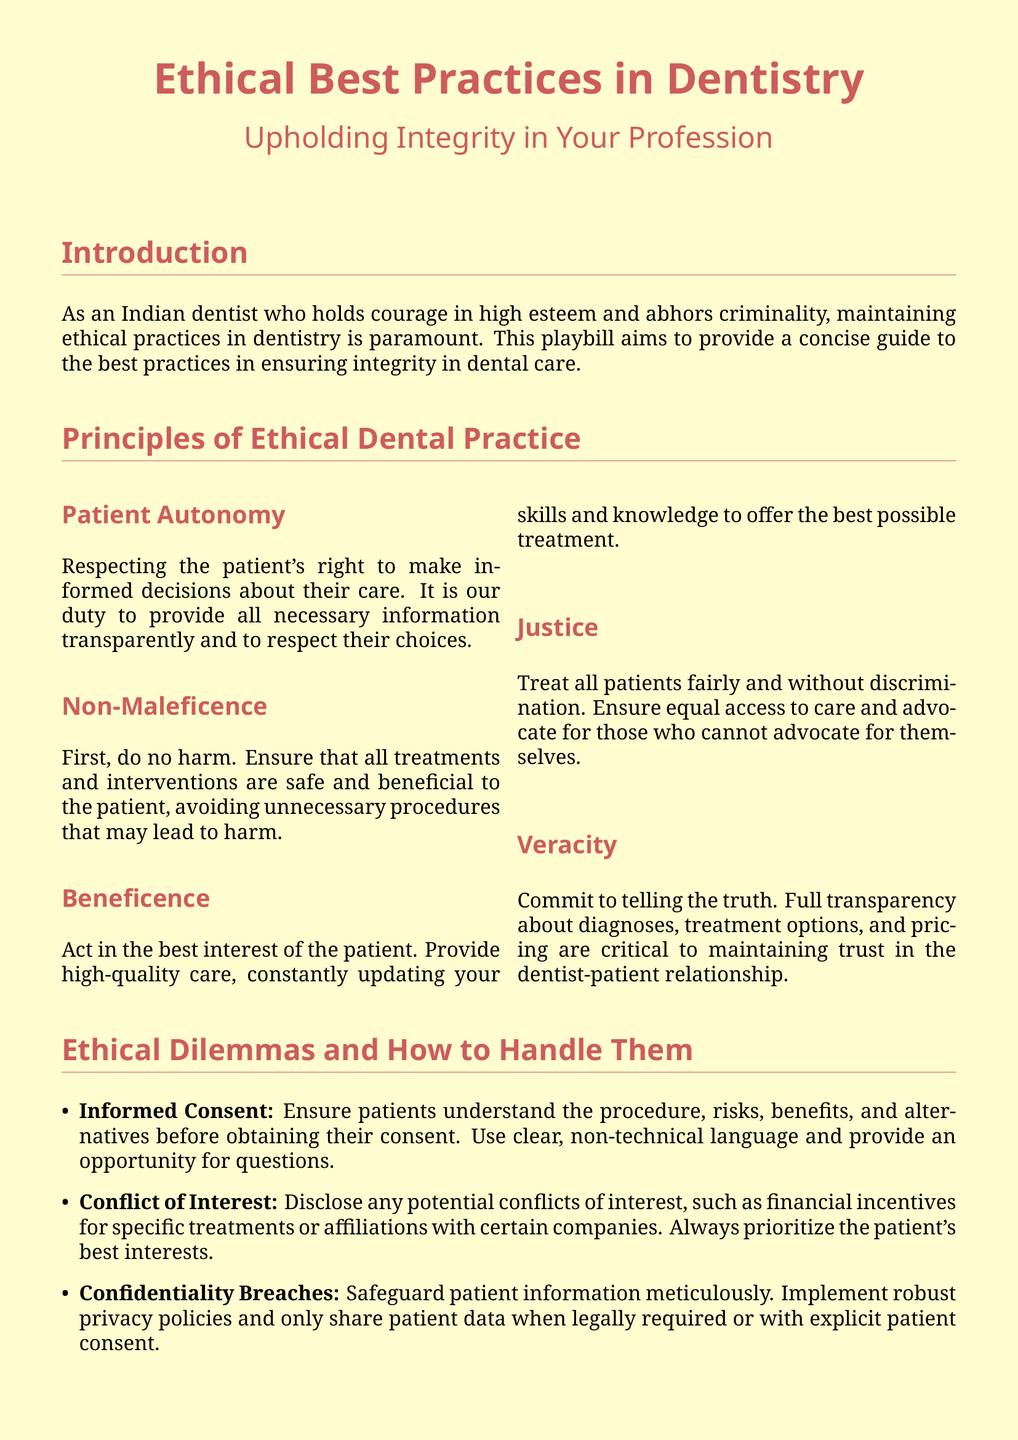What is the title of the playbill? The title of the playbill is prominently displayed at the top and clearly states the main subject of the document.
Answer: Ethical Best Practices in Dentistry Who is the case study about? The case study highlights a specific individual who exemplifies courage in ethical practice within dentistry.
Answer: Dr. Vandana Katara What principle emphasizes the importance of telling the truth in dentistry? One of the ethical principles outlined in the document specifically addresses honesty and transparency with patients.
Answer: Veracity What should be ensured before obtaining informed consent? The document outlines what must be communicated to the patient prior to giving consent for treatment.
Answer: Understanding of the procedure What is the primary focus of ethical dental practice? The principles highlighted in the document collectively guide ethical conduct in the field of dentistry.
Answer: Integrity 